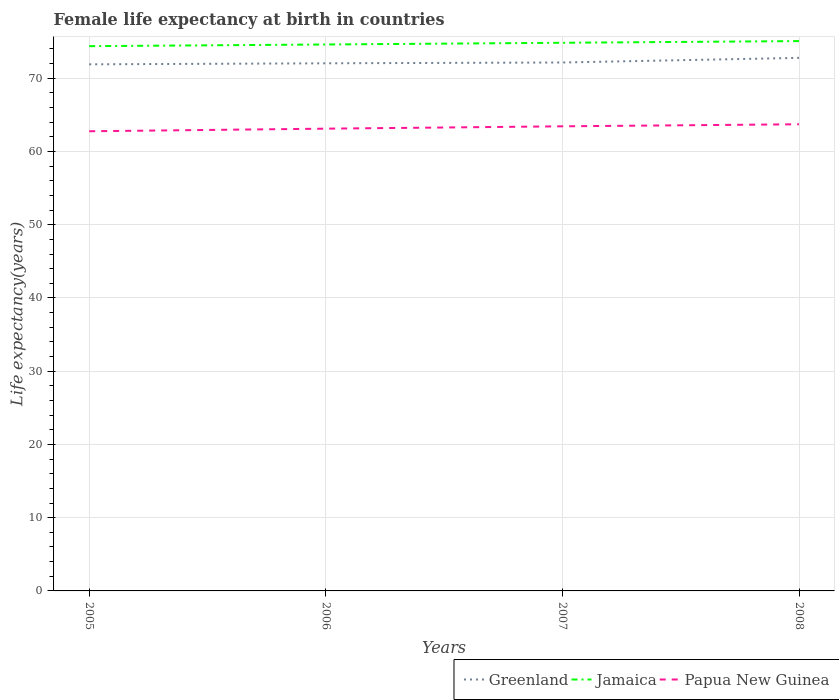How many different coloured lines are there?
Offer a very short reply. 3. Is the number of lines equal to the number of legend labels?
Your response must be concise. Yes. Across all years, what is the maximum female life expectancy at birth in Papua New Guinea?
Ensure brevity in your answer.  62.76. In which year was the female life expectancy at birth in Greenland maximum?
Offer a terse response. 2005. What is the total female life expectancy at birth in Papua New Guinea in the graph?
Your answer should be compact. -0.32. What is the difference between the highest and the second highest female life expectancy at birth in Papua New Guinea?
Your answer should be very brief. 0.95. What is the difference between the highest and the lowest female life expectancy at birth in Papua New Guinea?
Offer a very short reply. 2. Is the female life expectancy at birth in Greenland strictly greater than the female life expectancy at birth in Jamaica over the years?
Offer a terse response. Yes. How many lines are there?
Your answer should be very brief. 3. Are the values on the major ticks of Y-axis written in scientific E-notation?
Your answer should be compact. No. Does the graph contain any zero values?
Your answer should be very brief. No. Does the graph contain grids?
Provide a short and direct response. Yes. Where does the legend appear in the graph?
Offer a terse response. Bottom right. How many legend labels are there?
Provide a succinct answer. 3. How are the legend labels stacked?
Provide a succinct answer. Horizontal. What is the title of the graph?
Your answer should be compact. Female life expectancy at birth in countries. Does "Serbia" appear as one of the legend labels in the graph?
Your answer should be very brief. No. What is the label or title of the X-axis?
Offer a very short reply. Years. What is the label or title of the Y-axis?
Your answer should be very brief. Life expectancy(years). What is the Life expectancy(years) of Greenland in 2005?
Provide a short and direct response. 71.9. What is the Life expectancy(years) of Jamaica in 2005?
Your answer should be compact. 74.38. What is the Life expectancy(years) of Papua New Guinea in 2005?
Make the answer very short. 62.76. What is the Life expectancy(years) of Greenland in 2006?
Your answer should be compact. 72.04. What is the Life expectancy(years) of Jamaica in 2006?
Provide a short and direct response. 74.61. What is the Life expectancy(years) of Papua New Guinea in 2006?
Ensure brevity in your answer.  63.12. What is the Life expectancy(years) in Greenland in 2007?
Make the answer very short. 72.15. What is the Life expectancy(years) in Jamaica in 2007?
Ensure brevity in your answer.  74.84. What is the Life expectancy(years) of Papua New Guinea in 2007?
Your answer should be compact. 63.44. What is the Life expectancy(years) in Greenland in 2008?
Ensure brevity in your answer.  72.78. What is the Life expectancy(years) of Jamaica in 2008?
Make the answer very short. 75.07. What is the Life expectancy(years) in Papua New Guinea in 2008?
Make the answer very short. 63.71. Across all years, what is the maximum Life expectancy(years) of Greenland?
Keep it short and to the point. 72.78. Across all years, what is the maximum Life expectancy(years) of Jamaica?
Your answer should be very brief. 75.07. Across all years, what is the maximum Life expectancy(years) of Papua New Guinea?
Offer a very short reply. 63.71. Across all years, what is the minimum Life expectancy(years) of Greenland?
Make the answer very short. 71.9. Across all years, what is the minimum Life expectancy(years) of Jamaica?
Offer a terse response. 74.38. Across all years, what is the minimum Life expectancy(years) in Papua New Guinea?
Offer a terse response. 62.76. What is the total Life expectancy(years) of Greenland in the graph?
Your response must be concise. 288.87. What is the total Life expectancy(years) of Jamaica in the graph?
Your answer should be very brief. 298.9. What is the total Life expectancy(years) of Papua New Guinea in the graph?
Your answer should be very brief. 253.03. What is the difference between the Life expectancy(years) of Greenland in 2005 and that in 2006?
Your answer should be very brief. -0.14. What is the difference between the Life expectancy(years) in Jamaica in 2005 and that in 2006?
Give a very brief answer. -0.23. What is the difference between the Life expectancy(years) of Papua New Guinea in 2005 and that in 2006?
Make the answer very short. -0.35. What is the difference between the Life expectancy(years) in Greenland in 2005 and that in 2007?
Provide a succinct answer. -0.25. What is the difference between the Life expectancy(years) in Jamaica in 2005 and that in 2007?
Provide a succinct answer. -0.46. What is the difference between the Life expectancy(years) of Papua New Guinea in 2005 and that in 2007?
Ensure brevity in your answer.  -0.68. What is the difference between the Life expectancy(years) of Greenland in 2005 and that in 2008?
Your answer should be very brief. -0.88. What is the difference between the Life expectancy(years) in Jamaica in 2005 and that in 2008?
Make the answer very short. -0.69. What is the difference between the Life expectancy(years) of Papua New Guinea in 2005 and that in 2008?
Offer a very short reply. -0.95. What is the difference between the Life expectancy(years) in Greenland in 2006 and that in 2007?
Offer a terse response. -0.11. What is the difference between the Life expectancy(years) in Jamaica in 2006 and that in 2007?
Give a very brief answer. -0.23. What is the difference between the Life expectancy(years) of Papua New Guinea in 2006 and that in 2007?
Offer a very short reply. -0.32. What is the difference between the Life expectancy(years) in Greenland in 2006 and that in 2008?
Keep it short and to the point. -0.74. What is the difference between the Life expectancy(years) of Jamaica in 2006 and that in 2008?
Ensure brevity in your answer.  -0.46. What is the difference between the Life expectancy(years) in Papua New Guinea in 2006 and that in 2008?
Your answer should be compact. -0.6. What is the difference between the Life expectancy(years) of Greenland in 2007 and that in 2008?
Offer a terse response. -0.63. What is the difference between the Life expectancy(years) in Jamaica in 2007 and that in 2008?
Offer a very short reply. -0.23. What is the difference between the Life expectancy(years) in Papua New Guinea in 2007 and that in 2008?
Ensure brevity in your answer.  -0.28. What is the difference between the Life expectancy(years) of Greenland in 2005 and the Life expectancy(years) of Jamaica in 2006?
Provide a succinct answer. -2.71. What is the difference between the Life expectancy(years) in Greenland in 2005 and the Life expectancy(years) in Papua New Guinea in 2006?
Make the answer very short. 8.79. What is the difference between the Life expectancy(years) in Jamaica in 2005 and the Life expectancy(years) in Papua New Guinea in 2006?
Keep it short and to the point. 11.27. What is the difference between the Life expectancy(years) in Greenland in 2005 and the Life expectancy(years) in Jamaica in 2007?
Offer a terse response. -2.94. What is the difference between the Life expectancy(years) in Greenland in 2005 and the Life expectancy(years) in Papua New Guinea in 2007?
Ensure brevity in your answer.  8.46. What is the difference between the Life expectancy(years) of Jamaica in 2005 and the Life expectancy(years) of Papua New Guinea in 2007?
Make the answer very short. 10.94. What is the difference between the Life expectancy(years) in Greenland in 2005 and the Life expectancy(years) in Jamaica in 2008?
Keep it short and to the point. -3.17. What is the difference between the Life expectancy(years) of Greenland in 2005 and the Life expectancy(years) of Papua New Guinea in 2008?
Give a very brief answer. 8.19. What is the difference between the Life expectancy(years) in Jamaica in 2005 and the Life expectancy(years) in Papua New Guinea in 2008?
Provide a succinct answer. 10.67. What is the difference between the Life expectancy(years) of Greenland in 2006 and the Life expectancy(years) of Jamaica in 2007?
Your response must be concise. -2.8. What is the difference between the Life expectancy(years) in Greenland in 2006 and the Life expectancy(years) in Papua New Guinea in 2007?
Offer a terse response. 8.6. What is the difference between the Life expectancy(years) in Jamaica in 2006 and the Life expectancy(years) in Papua New Guinea in 2007?
Keep it short and to the point. 11.17. What is the difference between the Life expectancy(years) in Greenland in 2006 and the Life expectancy(years) in Jamaica in 2008?
Provide a succinct answer. -3.03. What is the difference between the Life expectancy(years) in Greenland in 2006 and the Life expectancy(years) in Papua New Guinea in 2008?
Keep it short and to the point. 8.33. What is the difference between the Life expectancy(years) of Jamaica in 2006 and the Life expectancy(years) of Papua New Guinea in 2008?
Offer a very short reply. 10.89. What is the difference between the Life expectancy(years) in Greenland in 2007 and the Life expectancy(years) in Jamaica in 2008?
Offer a very short reply. -2.92. What is the difference between the Life expectancy(years) in Greenland in 2007 and the Life expectancy(years) in Papua New Guinea in 2008?
Provide a short and direct response. 8.44. What is the difference between the Life expectancy(years) of Jamaica in 2007 and the Life expectancy(years) of Papua New Guinea in 2008?
Keep it short and to the point. 11.13. What is the average Life expectancy(years) in Greenland per year?
Your response must be concise. 72.22. What is the average Life expectancy(years) in Jamaica per year?
Make the answer very short. 74.73. What is the average Life expectancy(years) of Papua New Guinea per year?
Your answer should be compact. 63.26. In the year 2005, what is the difference between the Life expectancy(years) of Greenland and Life expectancy(years) of Jamaica?
Offer a very short reply. -2.48. In the year 2005, what is the difference between the Life expectancy(years) of Greenland and Life expectancy(years) of Papua New Guinea?
Give a very brief answer. 9.14. In the year 2005, what is the difference between the Life expectancy(years) of Jamaica and Life expectancy(years) of Papua New Guinea?
Your response must be concise. 11.62. In the year 2006, what is the difference between the Life expectancy(years) of Greenland and Life expectancy(years) of Jamaica?
Offer a very short reply. -2.57. In the year 2006, what is the difference between the Life expectancy(years) in Greenland and Life expectancy(years) in Papua New Guinea?
Offer a very short reply. 8.93. In the year 2006, what is the difference between the Life expectancy(years) of Jamaica and Life expectancy(years) of Papua New Guinea?
Your answer should be very brief. 11.49. In the year 2007, what is the difference between the Life expectancy(years) in Greenland and Life expectancy(years) in Jamaica?
Make the answer very short. -2.69. In the year 2007, what is the difference between the Life expectancy(years) of Greenland and Life expectancy(years) of Papua New Guinea?
Give a very brief answer. 8.71. In the year 2007, what is the difference between the Life expectancy(years) in Jamaica and Life expectancy(years) in Papua New Guinea?
Your response must be concise. 11.41. In the year 2008, what is the difference between the Life expectancy(years) of Greenland and Life expectancy(years) of Jamaica?
Offer a terse response. -2.29. In the year 2008, what is the difference between the Life expectancy(years) of Greenland and Life expectancy(years) of Papua New Guinea?
Your answer should be very brief. 9.07. In the year 2008, what is the difference between the Life expectancy(years) in Jamaica and Life expectancy(years) in Papua New Guinea?
Offer a terse response. 11.36. What is the ratio of the Life expectancy(years) in Greenland in 2005 to that in 2006?
Your answer should be very brief. 1. What is the ratio of the Life expectancy(years) in Jamaica in 2005 to that in 2006?
Provide a short and direct response. 1. What is the ratio of the Life expectancy(years) of Greenland in 2005 to that in 2008?
Give a very brief answer. 0.99. What is the ratio of the Life expectancy(years) in Greenland in 2006 to that in 2007?
Your answer should be very brief. 1. What is the ratio of the Life expectancy(years) in Papua New Guinea in 2006 to that in 2007?
Give a very brief answer. 0.99. What is the ratio of the Life expectancy(years) in Jamaica in 2006 to that in 2008?
Your answer should be compact. 0.99. What is the ratio of the Life expectancy(years) of Papua New Guinea in 2006 to that in 2008?
Give a very brief answer. 0.99. What is the ratio of the Life expectancy(years) of Papua New Guinea in 2007 to that in 2008?
Give a very brief answer. 1. What is the difference between the highest and the second highest Life expectancy(years) in Greenland?
Provide a short and direct response. 0.63. What is the difference between the highest and the second highest Life expectancy(years) of Jamaica?
Keep it short and to the point. 0.23. What is the difference between the highest and the second highest Life expectancy(years) in Papua New Guinea?
Make the answer very short. 0.28. What is the difference between the highest and the lowest Life expectancy(years) in Jamaica?
Your answer should be very brief. 0.69. What is the difference between the highest and the lowest Life expectancy(years) in Papua New Guinea?
Offer a terse response. 0.95. 